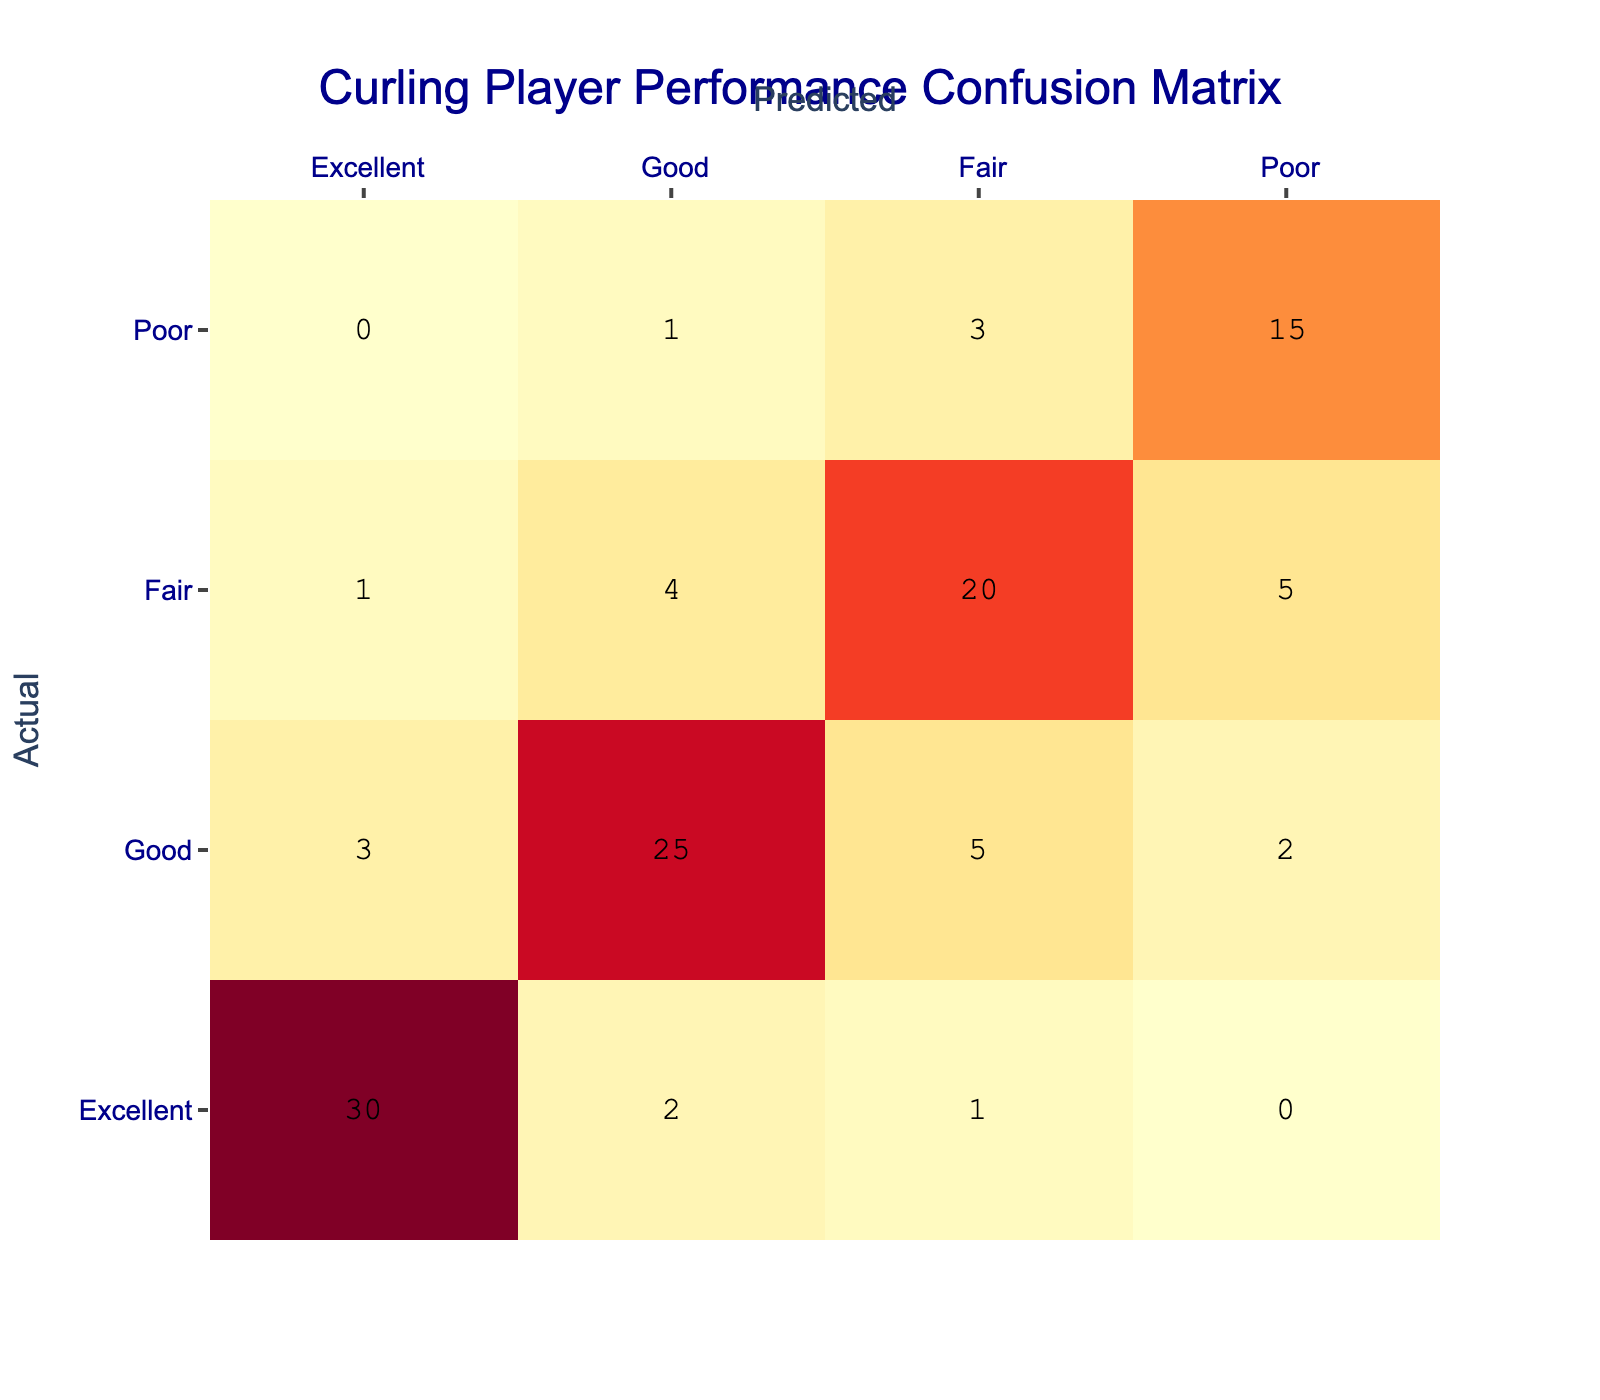What is the total number of players categorized as Excellent? To find the total number of players categorized as Excellent, we look at the "Excellent" row in the table. The values in this row are: 30 (Excellent), 2 (Good), 1 (Fair), and 0 (Poor). We sum these values: 30 + 2 + 1 + 0 = 33.
Answer: 33 How many players were incorrectly categorized as Excellent when they were actually Good? Referring to the "Good" row, we see that 3 players were predicted to be Excellent while their actual categorization was Good.
Answer: 3 What is the total number of players who performed Poorly, regardless of the predicted categorization? We need to add the values from the "Poor" row: 0 (Excellent), 1 (Good), 3 (Fair), and 15 (Poor). Summing these gives us 0 + 1 + 3 + 15 = 19 players who performed Poorly.
Answer: 19 Did more players perform Fairly than Poorly? To answer this, we need the total number of players performing Fairly and Poorly. From the "Fair" row, we have 1 (Excellent), 4 (Good), 20 (Fair), 5 (Poor) = 30 Fair. From the "Poor" row, we have 0 (Excellent), 1 (Good), 3 (Fair), and 15 (Poor) = 19 Poor. Since 30 > 19, the answer is yes.
Answer: Yes What percentage of players categorized as Fair were correctly predicted as Fair? Looking at the "Fair" row, 20 players were predicted as Fair (correct prediction) out of a total of 30 players performing Fair (1 Excellent, 4 Good, 20 Fair, 5 Poor). To find the percentage: (20/30) * 100 = 66.67%.
Answer: 66.67% How many players were misclassified as Poor when they were actually Fair? From the "Fair" row, we see there are 5 players who were actually Fair but were predicted as Poor.
Answer: 5 What is the ratio of players categorized as Poor to those categorized as Good? Categorizing the Poor players gives us a total of 19, while the Good players count totals to 35 (3 Excellent + 25 Good + 5 Fair + 2 Poor). The ratio is calculated as 19:35.
Answer: 19:35 Which performance category has the highest count of predictions? Observing the total values in each row: 30 (Excellent), 35 (Good), 30 (Fair), and 19 (Poor). The highest count is in the Good category with 35 players.
Answer: Good What is the difference in the number of players categorized as Excellent and categorized as Poor? The number of players categorized as Excellent is 33, and those categorized as Poor is 19. The difference is calculated as 33 - 19 = 14.
Answer: 14 